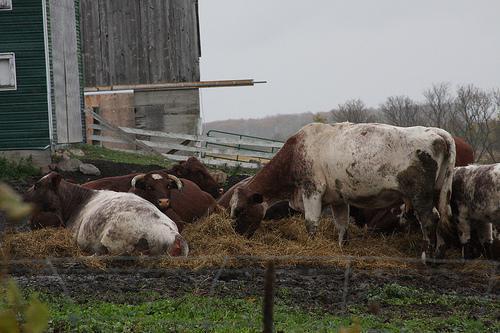How many buildings are there?
Give a very brief answer. 1. 